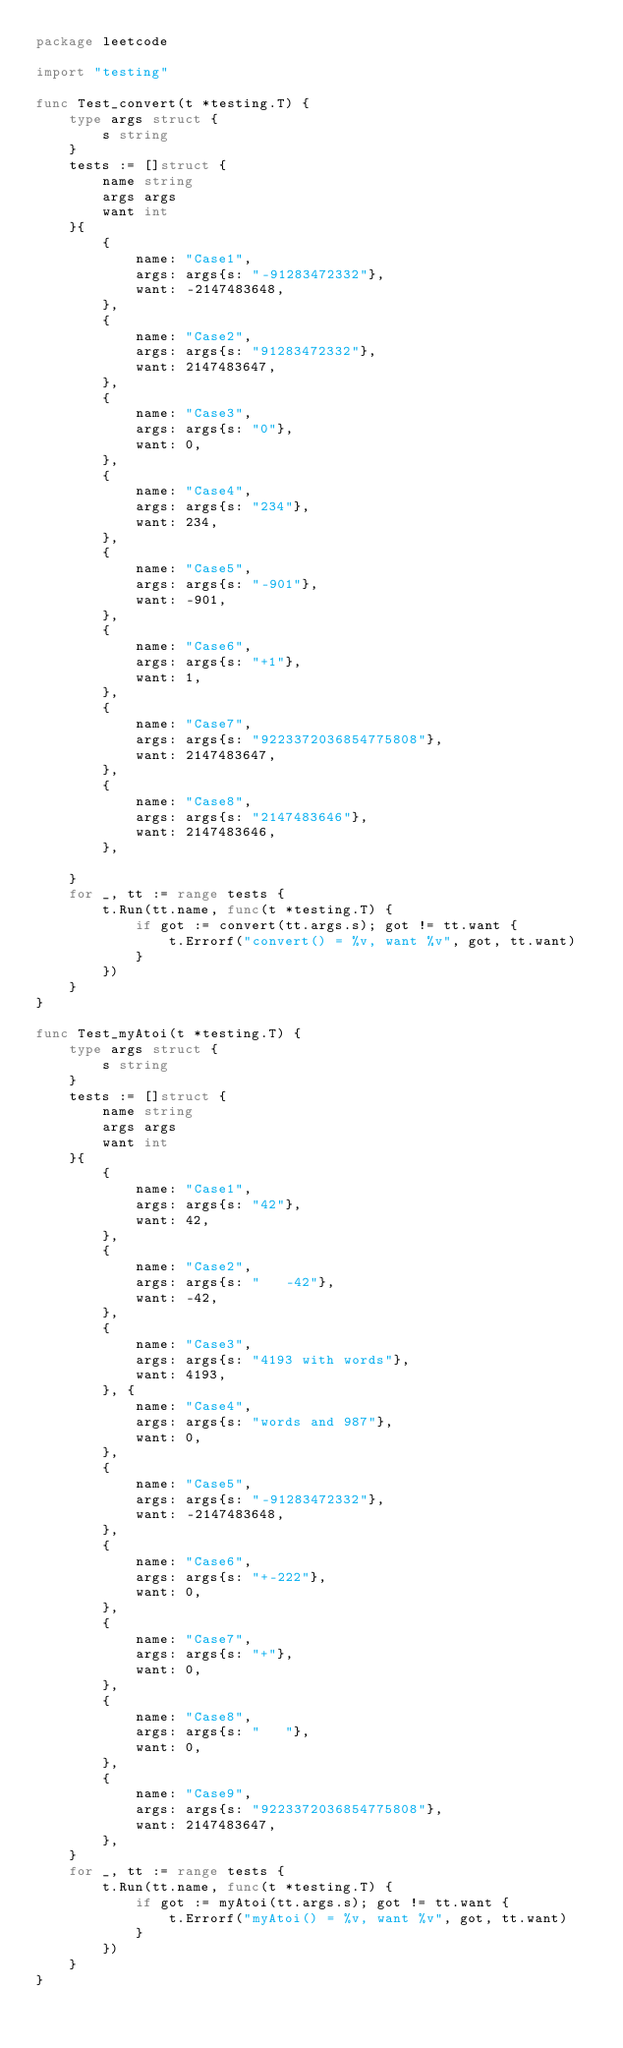Convert code to text. <code><loc_0><loc_0><loc_500><loc_500><_Go_>package leetcode

import "testing"

func Test_convert(t *testing.T) {
	type args struct {
		s string
	}
	tests := []struct {
		name string
		args args
		want int
	}{
		{
			name: "Case1",
			args: args{s: "-91283472332"},
			want: -2147483648,
		},
		{
			name: "Case2",
			args: args{s: "91283472332"},
			want: 2147483647,
		},
		{
			name: "Case3",
			args: args{s: "0"},
			want: 0,
		},
		{
			name: "Case4",
			args: args{s: "234"},
			want: 234,
		},
		{
			name: "Case5",
			args: args{s: "-901"},
			want: -901,
		},
		{
			name: "Case6",
			args: args{s: "+1"},
			want: 1,
		},
		{
			name: "Case7",
			args: args{s: "9223372036854775808"},
			want: 2147483647,
		},
		{
			name: "Case8",
			args: args{s: "2147483646"},
			want: 2147483646,
		},

	}
	for _, tt := range tests {
		t.Run(tt.name, func(t *testing.T) {
			if got := convert(tt.args.s); got != tt.want {
				t.Errorf("convert() = %v, want %v", got, tt.want)
			}
		})
	}
}

func Test_myAtoi(t *testing.T) {
	type args struct {
		s string
	}
	tests := []struct {
		name string
		args args
		want int
	}{
		{
			name: "Case1",
			args: args{s: "42"},
			want: 42,
		},
		{
			name: "Case2",
			args: args{s: "   -42"},
			want: -42,
		},
		{
			name: "Case3",
			args: args{s: "4193 with words"},
			want: 4193,
		}, {
			name: "Case4",
			args: args{s: "words and 987"},
			want: 0,
		},
		{
			name: "Case5",
			args: args{s: "-91283472332"},
			want: -2147483648,
		},
		{
			name: "Case6",
			args: args{s: "+-222"},
			want: 0,
		},
		{
			name: "Case7",
			args: args{s: "+"},
			want: 0,
		},
		{
			name: "Case8",
			args: args{s: "   "},
			want: 0,
		},
		{
			name: "Case9",
			args: args{s: "9223372036854775808"},
			want: 2147483647,
		},
	}
	for _, tt := range tests {
		t.Run(tt.name, func(t *testing.T) {
			if got := myAtoi(tt.args.s); got != tt.want {
				t.Errorf("myAtoi() = %v, want %v", got, tt.want)
			}
		})
	}
}
</code> 